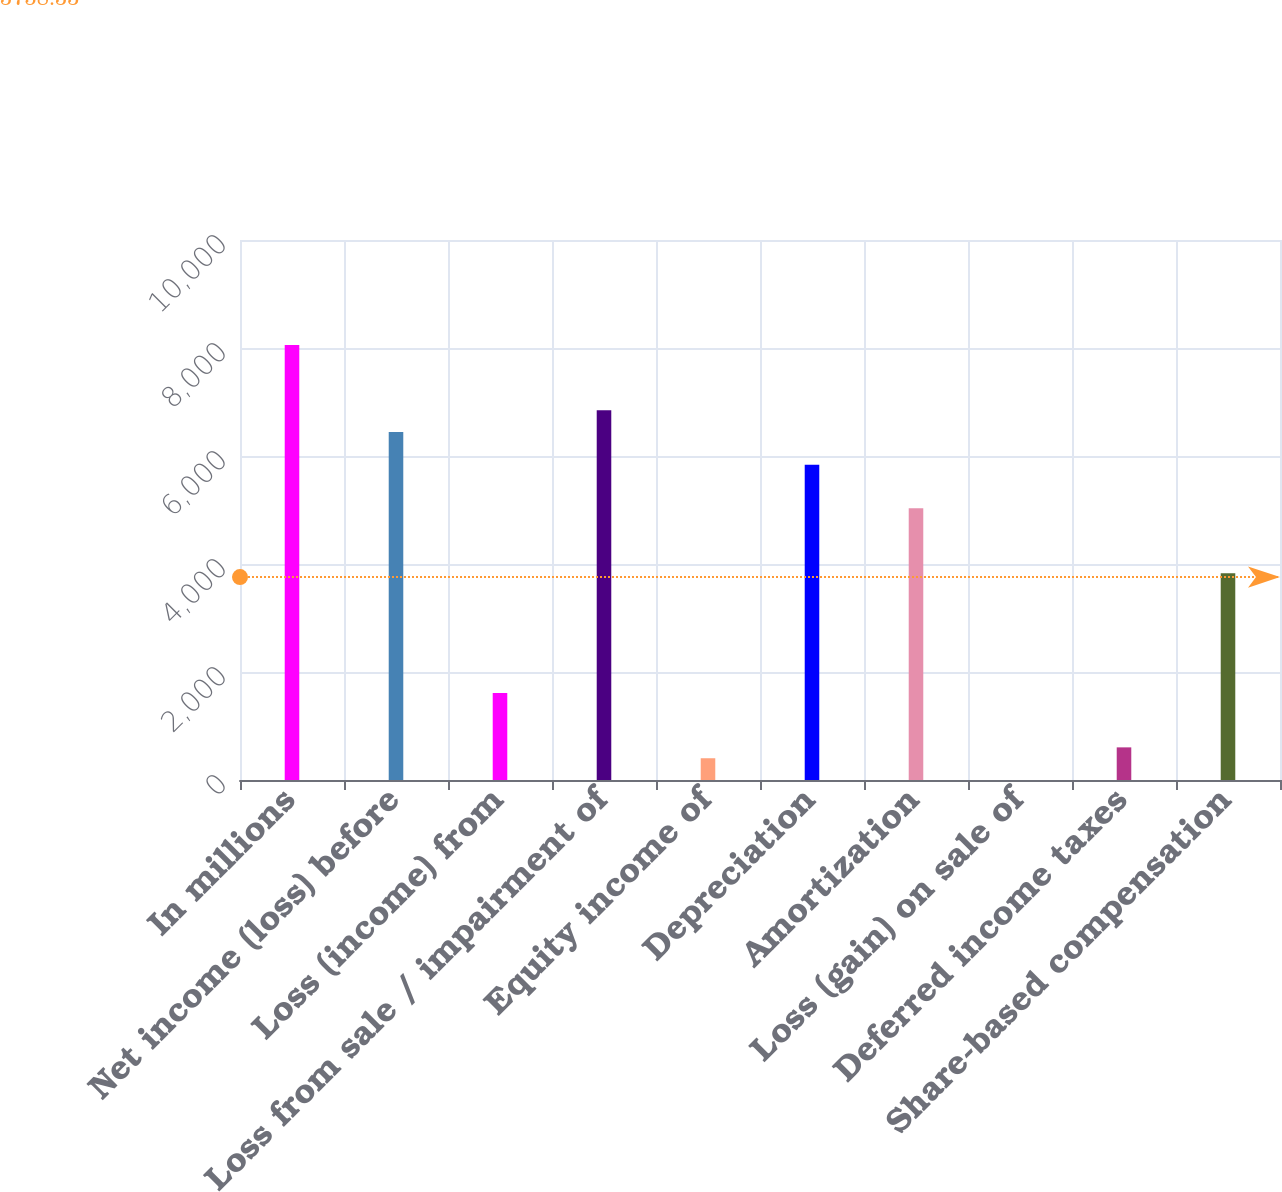Convert chart. <chart><loc_0><loc_0><loc_500><loc_500><bar_chart><fcel>In millions<fcel>Net income (loss) before<fcel>Loss (income) from<fcel>Loss from sale / impairment of<fcel>Equity income of<fcel>Depreciation<fcel>Amortization<fcel>Loss (gain) on sale of<fcel>Deferred income taxes<fcel>Share-based compensation<nl><fcel>8055.4<fcel>6444.36<fcel>1611.24<fcel>6847.12<fcel>402.96<fcel>5840.22<fcel>5034.7<fcel>0.2<fcel>604.34<fcel>3826.42<nl></chart> 